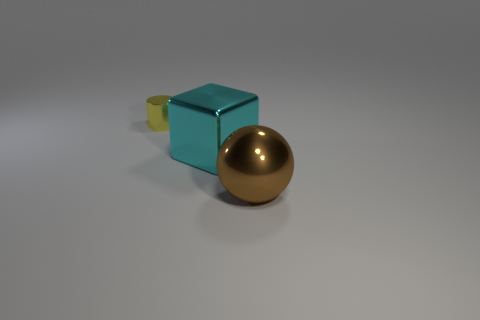What number of yellow objects have the same material as the cyan block?
Keep it short and to the point. 1. There is a object right of the cyan metal object; is it the same size as the big block?
Your response must be concise. Yes. What color is the block that is made of the same material as the yellow object?
Make the answer very short. Cyan. Are there any other things that are the same size as the shiny cylinder?
Provide a succinct answer. No. What number of cyan objects are in front of the tiny yellow metallic cylinder?
Keep it short and to the point. 1. Is there any other thing that has the same shape as the cyan object?
Provide a short and direct response. No. There is a big shiny object that is behind the big ball; does it have the same shape as the big object that is on the right side of the shiny cube?
Provide a short and direct response. No. There is a brown object; does it have the same size as the shiny object that is to the left of the big cyan shiny block?
Your answer should be very brief. No. Are there more big green shiny blocks than shiny cubes?
Ensure brevity in your answer.  No. Is the thing left of the cyan metallic cube made of the same material as the thing to the right of the cyan cube?
Offer a terse response. Yes. 